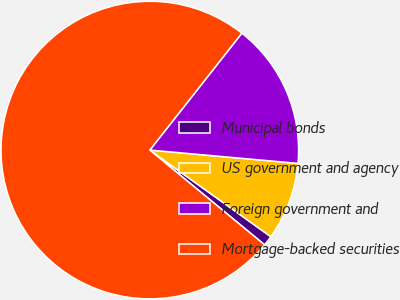Convert chart. <chart><loc_0><loc_0><loc_500><loc_500><pie_chart><fcel>Municipal bonds<fcel>US government and agency<fcel>Foreign government and<fcel>Mortgage-backed securities<nl><fcel>1.1%<fcel>8.46%<fcel>15.81%<fcel>74.63%<nl></chart> 